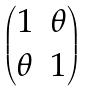<formula> <loc_0><loc_0><loc_500><loc_500>\begin{pmatrix} 1 & \theta \\ \theta & 1 \end{pmatrix}</formula> 